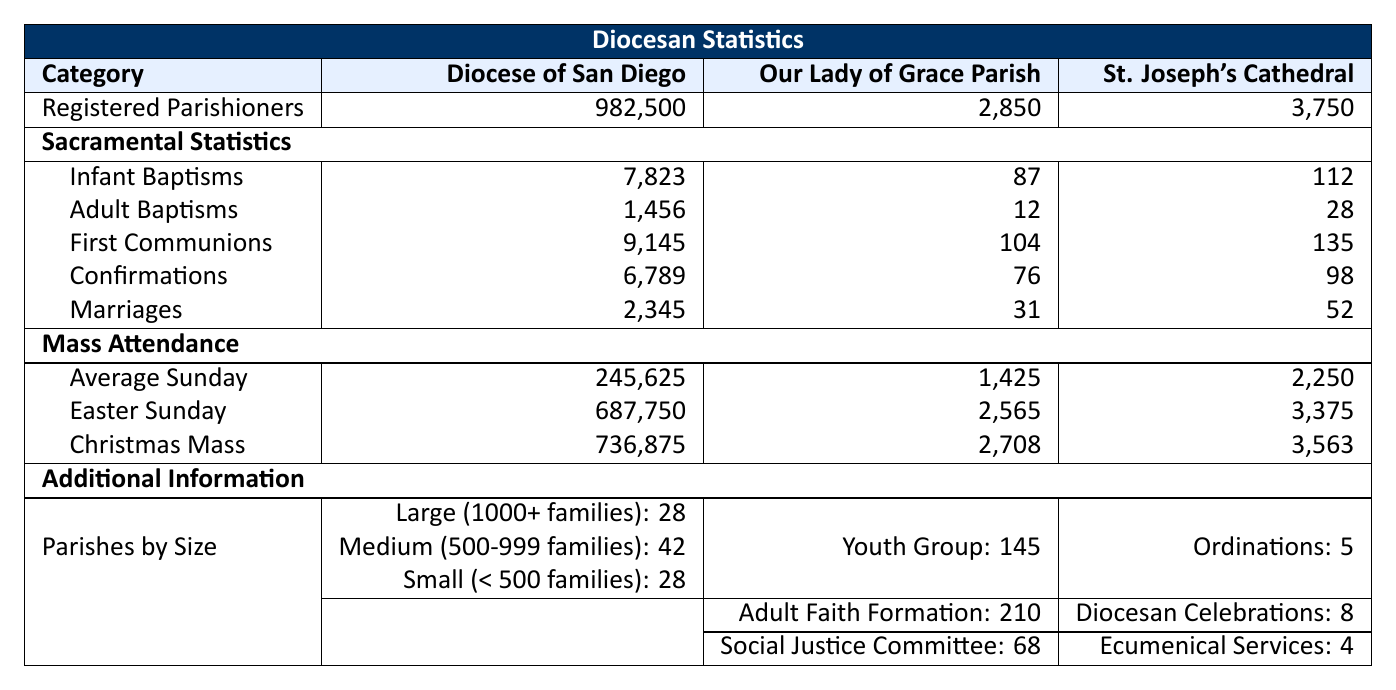What is the total number of registered parishioners in the Diocese of San Diego? The table states that the total registered parishioners in the Diocese of San Diego is 982,500.
Answer: 982,500 How many marriages were recorded at St. Joseph's Cathedral? The table indicates that St. Joseph's Cathedral had 52 marriages in the past year.
Answer: 52 What is the average Sunday attendance at Our Lady of Grace Parish? According to the table, the average Sunday attendance at Our Lady of Grace Parish is 1,425.
Answer: 1,425 How many total infant baptisms were recorded in the Diocese of San Diego? The table shows that there were 7,823 infant baptisms in the Diocese of San Diego.
Answer: 7,823 Which parish had the highest Easter Sunday attendance? The table lists that the Diocese of San Diego had 687,750 attendees for Easter Sunday, which is higher than the other parishes: 2,565 for Our Lady of Grace Parish and 3,375 for St. Joseph's Cathedral.
Answer: Diocese of San Diego What is the difference in average Sunday attendance between the Diocese of San Diego and St. Joseph's Cathedral? The average Sunday attendance for the Diocese of San Diego is 245,625, while for St. Joseph's Cathedral it is 2,250. The difference is 245,625 - 2,250 = 243,375.
Answer: 243,375 What percentage of total registered parishioners does Our Lady of Grace Parish represent? Our Lady of Grace Parish has 2,850 registered parishioners, and the Diocese has 982,500. The percentage is calculated as (2,850 / 982,500) * 100 = 0.290%.
Answer: 0.290% Which parish had more than 100 adult baptisms? The table reveals that St. Joseph's Cathedral had 28 adult baptisms and Our Lady of Grace Parish had 12 adult baptisms, while the Diocese of San Diego had 1,456 adult baptisms. Thus, only the Diocese of San Diego exceeds 100 adult baptisms.
Answer: Diocese of San Diego How many total people attended Christmas Mass across all three locations? The table provides the attendance numbers: Diocese of San Diego: 736,875, Our Lady of Grace Parish: 2,708, and St. Joseph's Cathedral: 3,563. The total attendance is 736,875 + 2,708 + 3,563 = 743,146.
Answer: 743,146 What proportion of confirmed individuals at Our Lady of Grace Parish participated in the youth group? There were 76 confirmations at Our Lady of Grace Parish and 145 youth group participants. The proportion is calculated as 145 / 76 = 1.912 approximately, meaning approximately 192% of confirmed individuals participated in the youth group.
Answer: 192% Is the number of average Sunday attendees at St. Joseph's Cathedral less than that at Our Lady of Grace Parish? St. Joseph's Cathedral has an average Sunday attendance of 2,250 while Our Lady of Grace Parish has 1,425, hence it is false; St. Joseph's Cathedral has more attendees.
Answer: No 